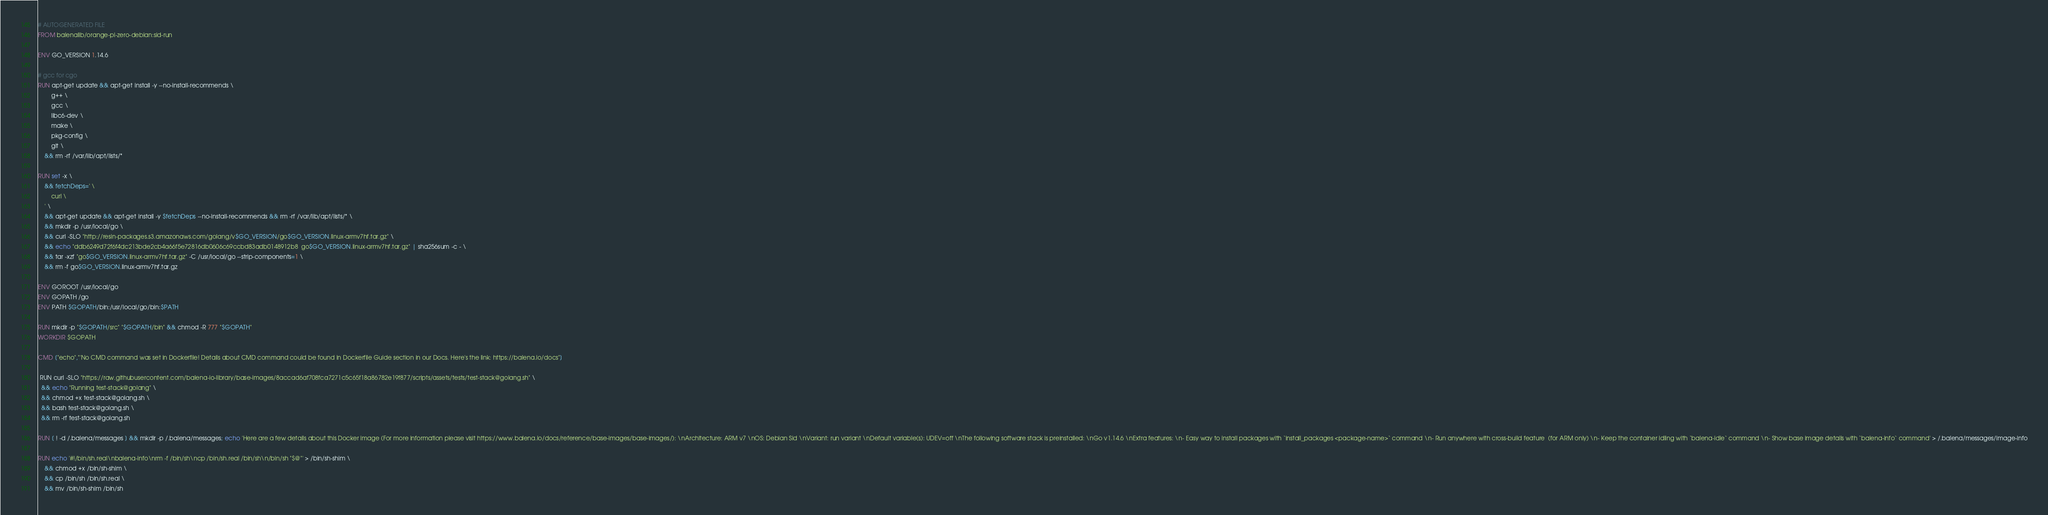<code> <loc_0><loc_0><loc_500><loc_500><_Dockerfile_># AUTOGENERATED FILE
FROM balenalib/orange-pi-zero-debian:sid-run

ENV GO_VERSION 1.14.6

# gcc for cgo
RUN apt-get update && apt-get install -y --no-install-recommends \
		g++ \
		gcc \
		libc6-dev \
		make \
		pkg-config \
		git \
	&& rm -rf /var/lib/apt/lists/*

RUN set -x \
	&& fetchDeps=' \
		curl \
	' \
	&& apt-get update && apt-get install -y $fetchDeps --no-install-recommends && rm -rf /var/lib/apt/lists/* \
	&& mkdir -p /usr/local/go \
	&& curl -SLO "http://resin-packages.s3.amazonaws.com/golang/v$GO_VERSION/go$GO_VERSION.linux-armv7hf.tar.gz" \
	&& echo "ddb6249d72f6f4dc213bde2cb4a66f5e72816db0606c69ccbd83adb0148912b8  go$GO_VERSION.linux-armv7hf.tar.gz" | sha256sum -c - \
	&& tar -xzf "go$GO_VERSION.linux-armv7hf.tar.gz" -C /usr/local/go --strip-components=1 \
	&& rm -f go$GO_VERSION.linux-armv7hf.tar.gz

ENV GOROOT /usr/local/go
ENV GOPATH /go
ENV PATH $GOPATH/bin:/usr/local/go/bin:$PATH

RUN mkdir -p "$GOPATH/src" "$GOPATH/bin" && chmod -R 777 "$GOPATH"
WORKDIR $GOPATH

CMD ["echo","'No CMD command was set in Dockerfile! Details about CMD command could be found in Dockerfile Guide section in our Docs. Here's the link: https://balena.io/docs"]

 RUN curl -SLO "https://raw.githubusercontent.com/balena-io-library/base-images/8accad6af708fca7271c5c65f18a86782e19f877/scripts/assets/tests/test-stack@golang.sh" \
  && echo "Running test-stack@golang" \
  && chmod +x test-stack@golang.sh \
  && bash test-stack@golang.sh \
  && rm -rf test-stack@golang.sh 

RUN [ ! -d /.balena/messages ] && mkdir -p /.balena/messages; echo 'Here are a few details about this Docker image (For more information please visit https://www.balena.io/docs/reference/base-images/base-images/): \nArchitecture: ARM v7 \nOS: Debian Sid \nVariant: run variant \nDefault variable(s): UDEV=off \nThe following software stack is preinstalled: \nGo v1.14.6 \nExtra features: \n- Easy way to install packages with `install_packages <package-name>` command \n- Run anywhere with cross-build feature  (for ARM only) \n- Keep the container idling with `balena-idle` command \n- Show base image details with `balena-info` command' > /.balena/messages/image-info

RUN echo '#!/bin/sh.real\nbalena-info\nrm -f /bin/sh\ncp /bin/sh.real /bin/sh\n/bin/sh "$@"' > /bin/sh-shim \
	&& chmod +x /bin/sh-shim \
	&& cp /bin/sh /bin/sh.real \
	&& mv /bin/sh-shim /bin/sh</code> 